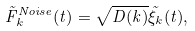Convert formula to latex. <formula><loc_0><loc_0><loc_500><loc_500>\tilde { F } _ { k } ^ { N o i s e } ( t ) = \sqrt { D ( k ) } \tilde { \xi } _ { k } ( t ) ,</formula> 